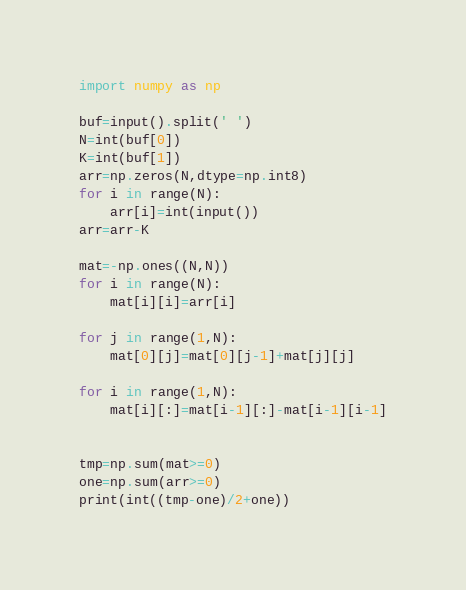<code> <loc_0><loc_0><loc_500><loc_500><_Python_>import numpy as np

buf=input().split(' ')
N=int(buf[0])
K=int(buf[1])
arr=np.zeros(N,dtype=np.int8)
for i in range(N):
    arr[i]=int(input())
arr=arr-K

mat=-np.ones((N,N))
for i in range(N):
    mat[i][i]=arr[i]
    
for j in range(1,N):
    mat[0][j]=mat[0][j-1]+mat[j][j]

for i in range(1,N):
    mat[i][:]=mat[i-1][:]-mat[i-1][i-1]

    
tmp=np.sum(mat>=0)
one=np.sum(arr>=0)
print(int((tmp-one)/2+one))</code> 